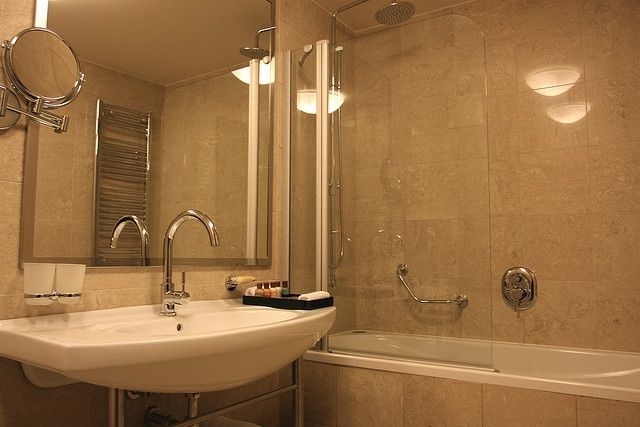Describe the objects in this image and their specific colors. I can see sink in tan and olive tones, cup in tan, gray, and olive tones, and cup in tan tones in this image. 